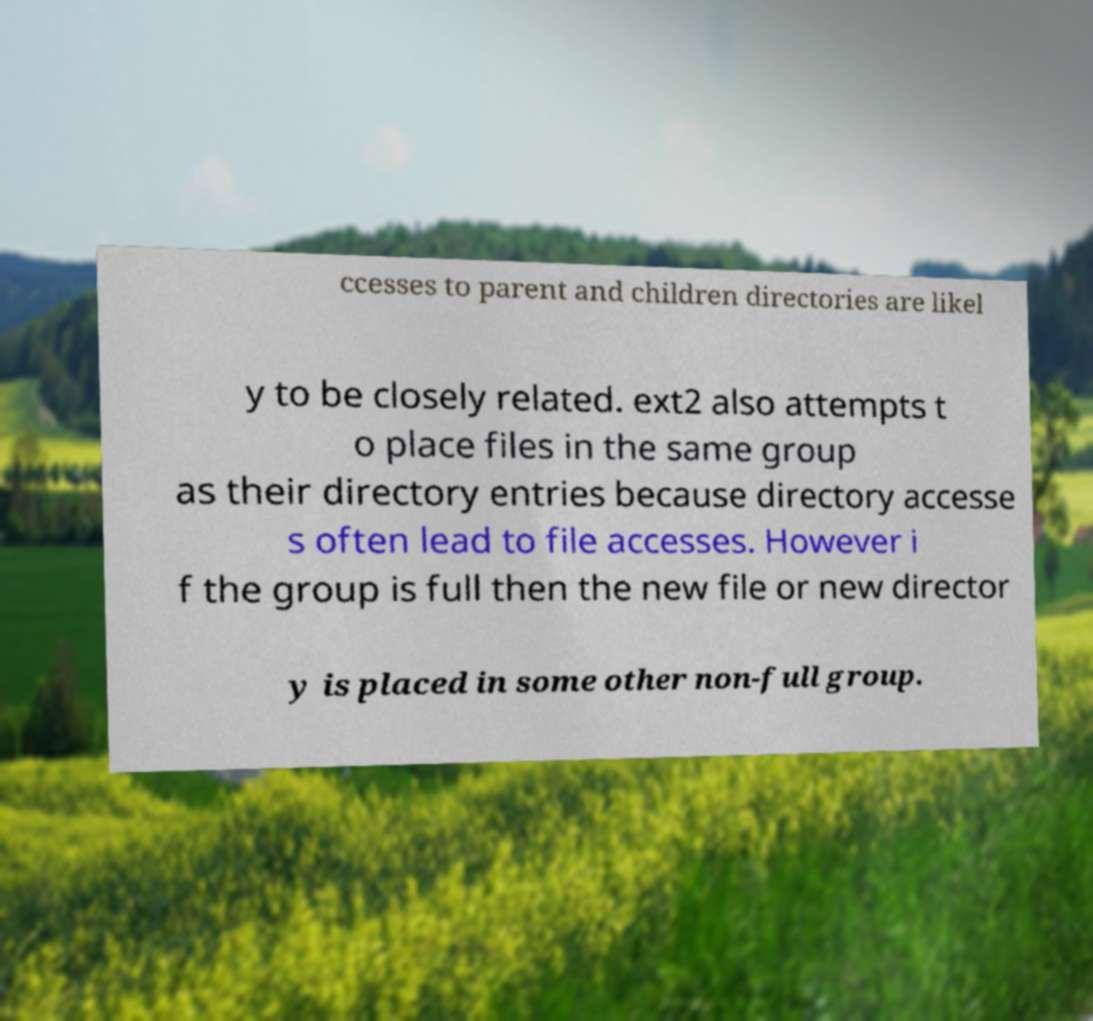Please identify and transcribe the text found in this image. ccesses to parent and children directories are likel y to be closely related. ext2 also attempts t o place files in the same group as their directory entries because directory accesse s often lead to file accesses. However i f the group is full then the new file or new director y is placed in some other non-full group. 